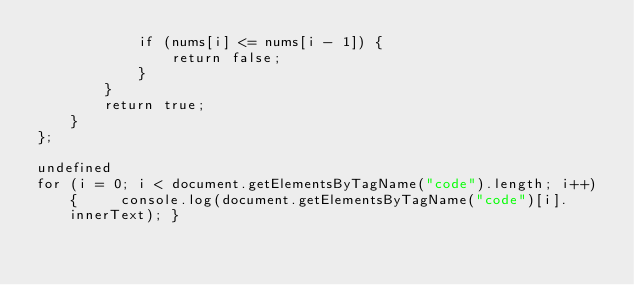Convert code to text. <code><loc_0><loc_0><loc_500><loc_500><_Java_>            if (nums[i] <= nums[i - 1]) {
                return false;
            }
        }
        return true;
    }
};

undefined
for (i = 0; i < document.getElementsByTagName("code").length; i++) {     console.log(document.getElementsByTagName("code")[i].innerText); }


</code> 